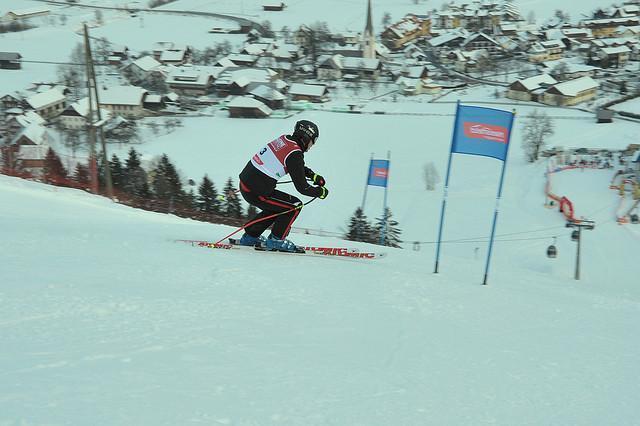How many poles?
Give a very brief answer. 2. 